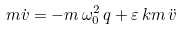Convert formula to latex. <formula><loc_0><loc_0><loc_500><loc_500>m \dot { v } = - m \, \omega _ { 0 } ^ { 2 } \, q + \varepsilon \, k m \, \ddot { v }</formula> 